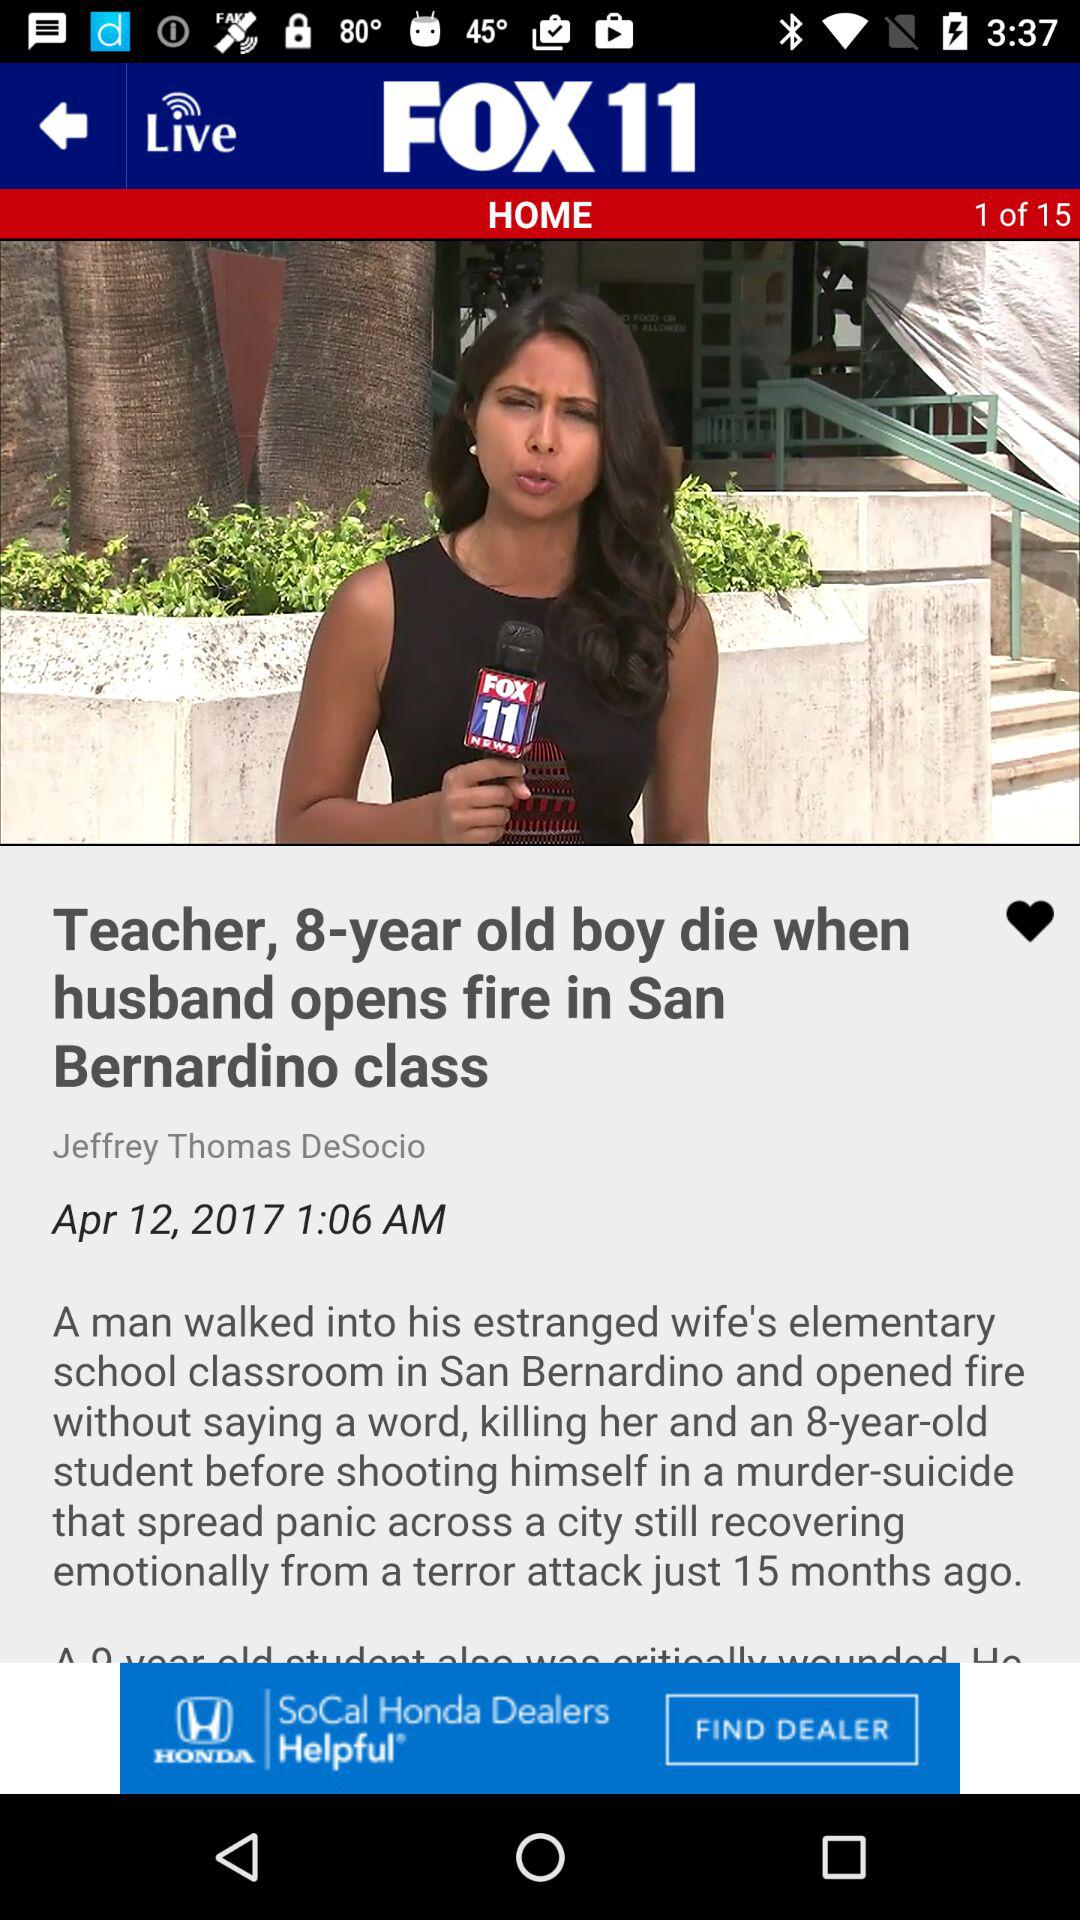At what time was the news about the eight-year-old boy who died in a fire in San Bernardino class published? The news about the eight-year-old boy who died in a fire in San Bernardino class was published at 1:06 AM. 